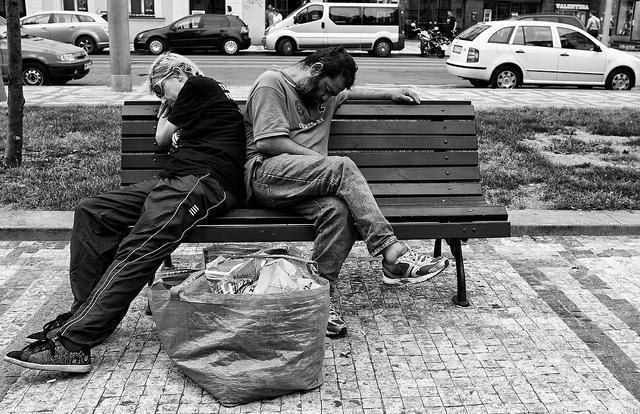What vehicle on the north side of the street will the car traveling west pass second?
Select the accurate response from the four choices given to answer the question.
Options: Motorcycle, light 4-door, white van, black 4-door. White van. 